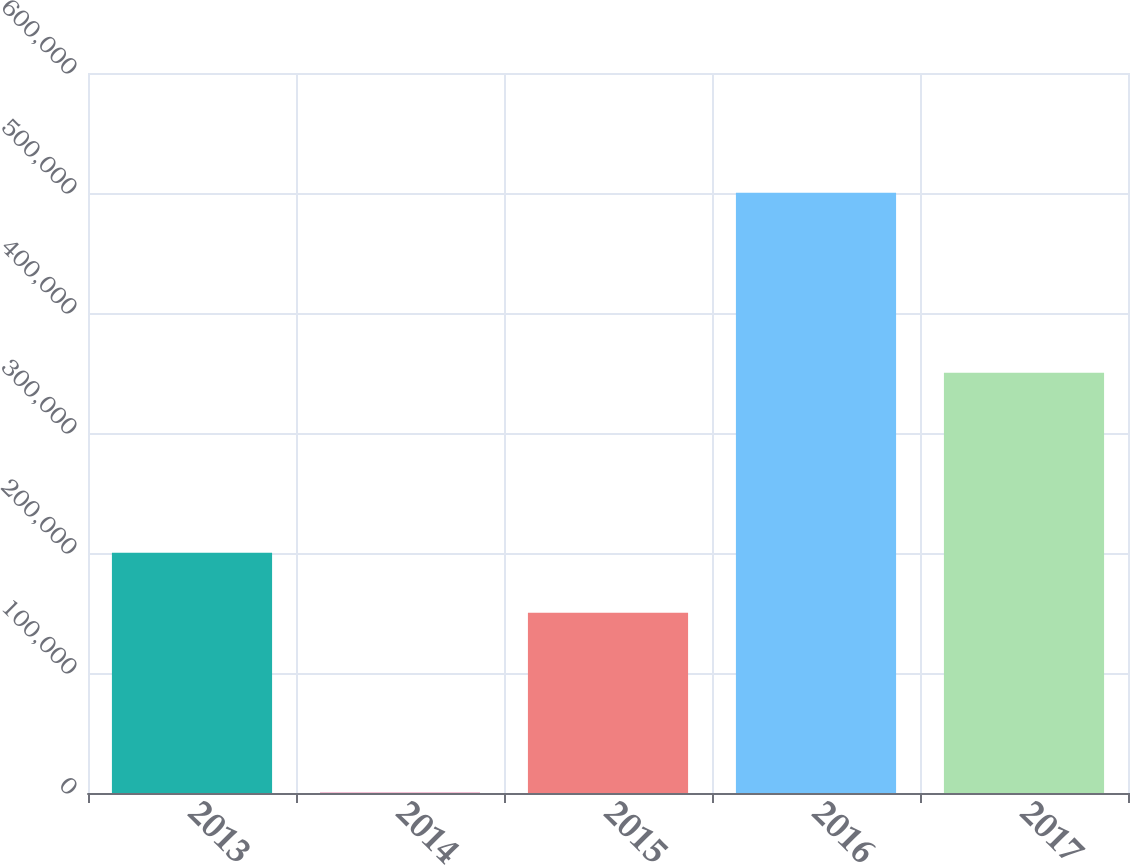<chart> <loc_0><loc_0><loc_500><loc_500><bar_chart><fcel>2013<fcel>2014<fcel>2015<fcel>2016<fcel>2017<nl><fcel>200133<fcel>170<fcel>150137<fcel>500130<fcel>350138<nl></chart> 